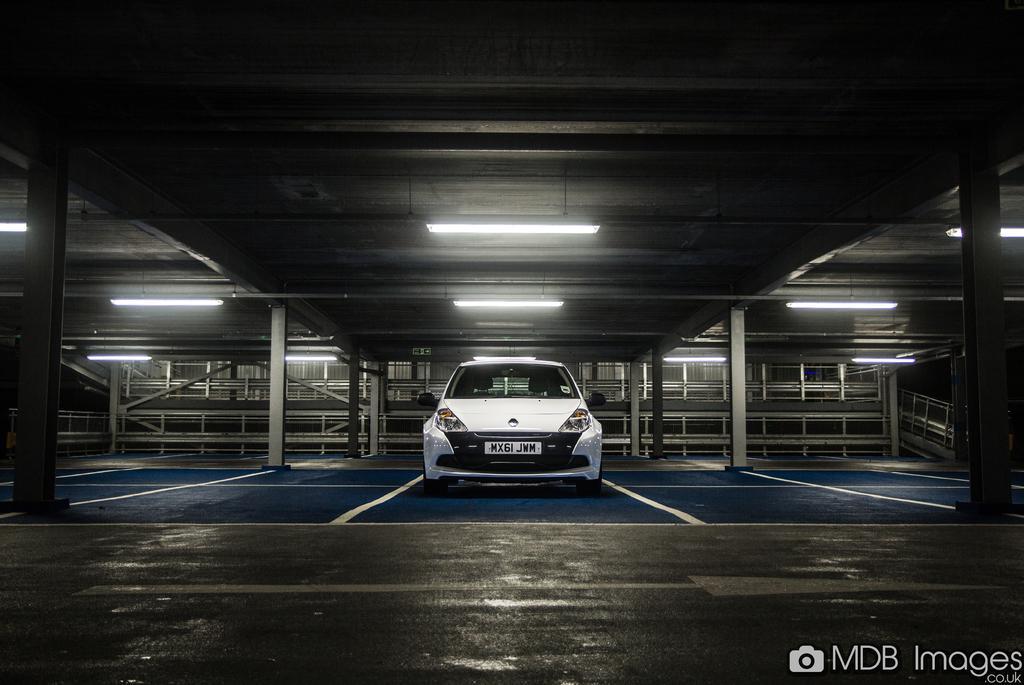Please provide a concise description of this image. In this image I can see the vehicle which is in white color. It is in the parking-lot. I can see many lights at the top and I can see few metal rods in the back. 